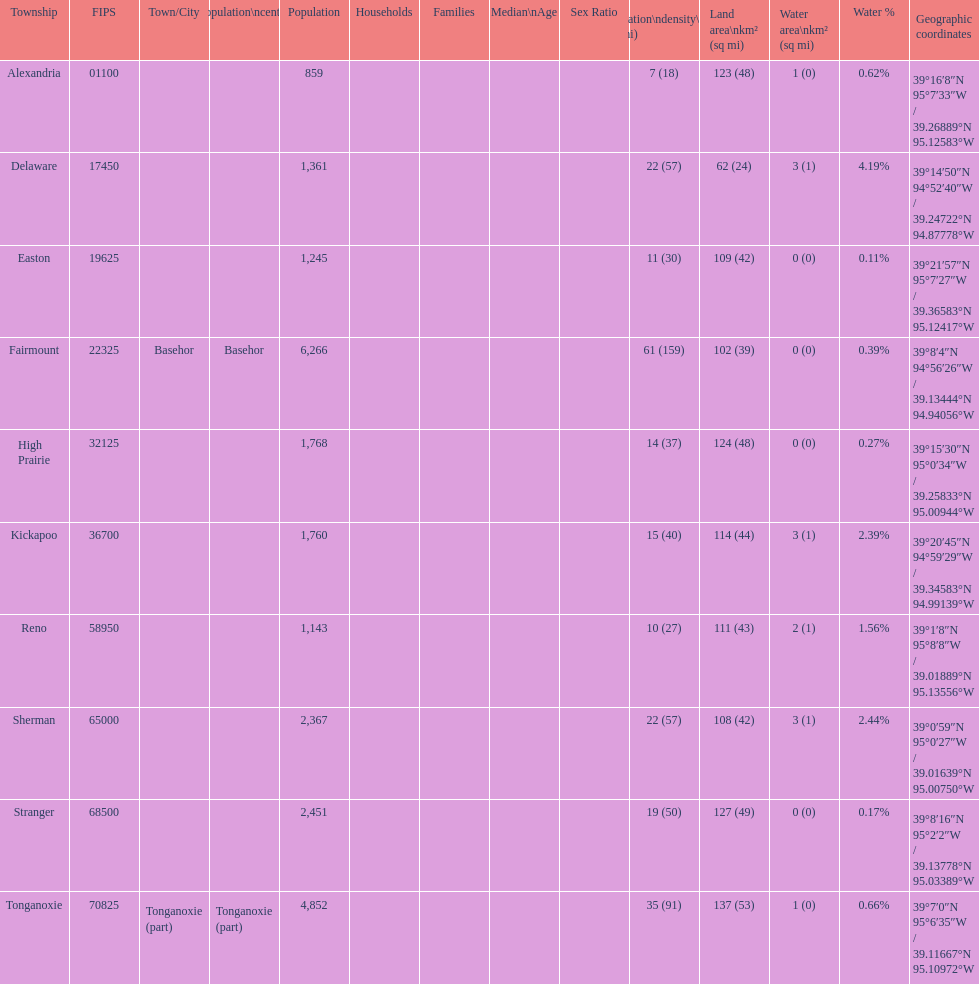Does alexandria county have a higher or lower population than delaware county? Lower. 